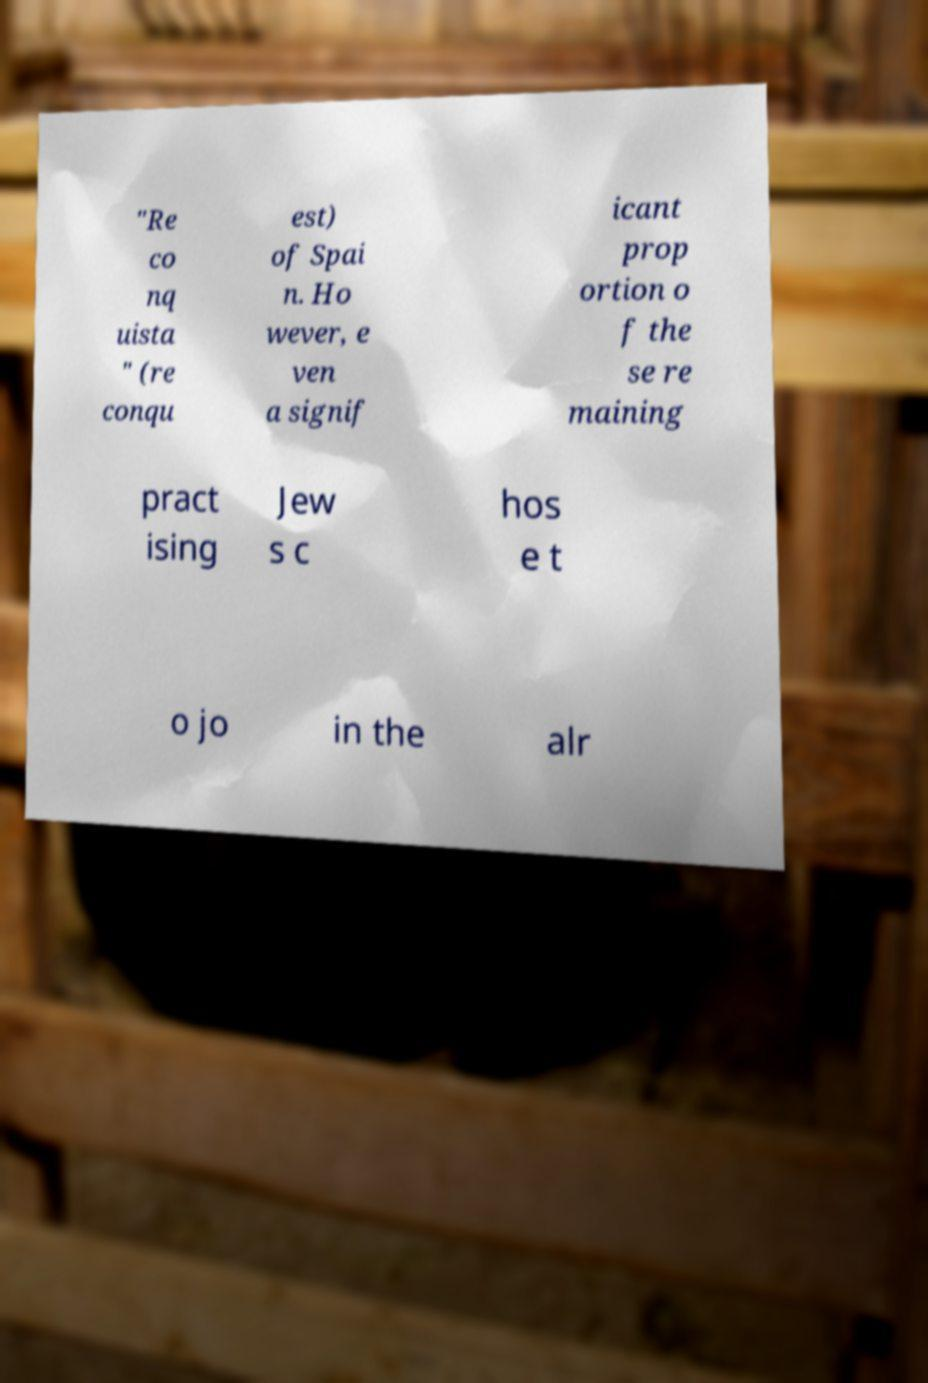Can you accurately transcribe the text from the provided image for me? "Re co nq uista " (re conqu est) of Spai n. Ho wever, e ven a signif icant prop ortion o f the se re maining pract ising Jew s c hos e t o jo in the alr 